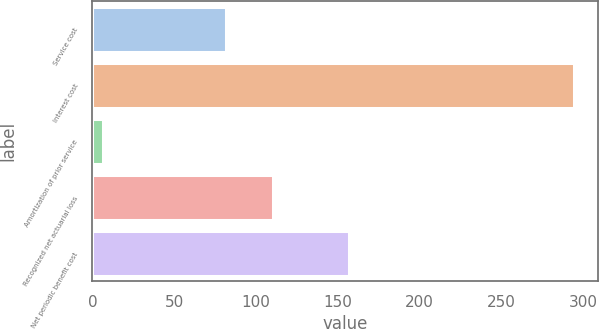Convert chart. <chart><loc_0><loc_0><loc_500><loc_500><bar_chart><fcel>Service cost<fcel>Interest cost<fcel>Amortization of prior service<fcel>Recognized net actuarial loss<fcel>Net periodic benefit cost<nl><fcel>81.4<fcel>294.6<fcel>6.3<fcel>110.23<fcel>156.8<nl></chart> 